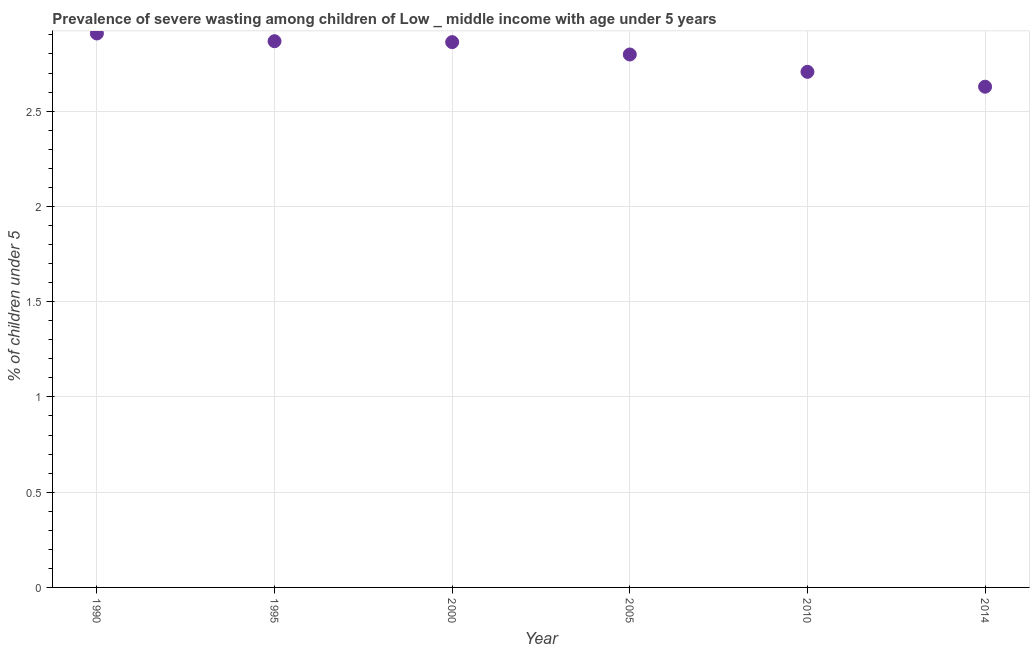What is the prevalence of severe wasting in 2005?
Your response must be concise. 2.8. Across all years, what is the maximum prevalence of severe wasting?
Ensure brevity in your answer.  2.91. Across all years, what is the minimum prevalence of severe wasting?
Keep it short and to the point. 2.63. In which year was the prevalence of severe wasting minimum?
Offer a very short reply. 2014. What is the sum of the prevalence of severe wasting?
Offer a very short reply. 16.77. What is the difference between the prevalence of severe wasting in 1995 and 2000?
Provide a short and direct response. 0. What is the average prevalence of severe wasting per year?
Ensure brevity in your answer.  2.79. What is the median prevalence of severe wasting?
Your answer should be compact. 2.83. Do a majority of the years between 2000 and 2005 (inclusive) have prevalence of severe wasting greater than 0.8 %?
Your response must be concise. Yes. What is the ratio of the prevalence of severe wasting in 1995 to that in 2000?
Keep it short and to the point. 1. Is the prevalence of severe wasting in 2005 less than that in 2010?
Provide a short and direct response. No. What is the difference between the highest and the second highest prevalence of severe wasting?
Ensure brevity in your answer.  0.04. Is the sum of the prevalence of severe wasting in 2000 and 2005 greater than the maximum prevalence of severe wasting across all years?
Provide a succinct answer. Yes. What is the difference between the highest and the lowest prevalence of severe wasting?
Your answer should be compact. 0.28. In how many years, is the prevalence of severe wasting greater than the average prevalence of severe wasting taken over all years?
Offer a very short reply. 4. Does the prevalence of severe wasting monotonically increase over the years?
Your response must be concise. No. How many years are there in the graph?
Offer a very short reply. 6. Does the graph contain grids?
Offer a very short reply. Yes. What is the title of the graph?
Provide a short and direct response. Prevalence of severe wasting among children of Low _ middle income with age under 5 years. What is the label or title of the Y-axis?
Make the answer very short.  % of children under 5. What is the  % of children under 5 in 1990?
Provide a short and direct response. 2.91. What is the  % of children under 5 in 1995?
Provide a short and direct response. 2.87. What is the  % of children under 5 in 2000?
Keep it short and to the point. 2.86. What is the  % of children under 5 in 2005?
Offer a terse response. 2.8. What is the  % of children under 5 in 2010?
Make the answer very short. 2.71. What is the  % of children under 5 in 2014?
Provide a short and direct response. 2.63. What is the difference between the  % of children under 5 in 1990 and 1995?
Give a very brief answer. 0.04. What is the difference between the  % of children under 5 in 1990 and 2000?
Offer a terse response. 0.05. What is the difference between the  % of children under 5 in 1990 and 2005?
Give a very brief answer. 0.11. What is the difference between the  % of children under 5 in 1990 and 2010?
Offer a terse response. 0.2. What is the difference between the  % of children under 5 in 1990 and 2014?
Keep it short and to the point. 0.28. What is the difference between the  % of children under 5 in 1995 and 2000?
Offer a terse response. 0. What is the difference between the  % of children under 5 in 1995 and 2005?
Your response must be concise. 0.07. What is the difference between the  % of children under 5 in 1995 and 2010?
Give a very brief answer. 0.16. What is the difference between the  % of children under 5 in 1995 and 2014?
Offer a terse response. 0.24. What is the difference between the  % of children under 5 in 2000 and 2005?
Provide a succinct answer. 0.06. What is the difference between the  % of children under 5 in 2000 and 2010?
Your response must be concise. 0.16. What is the difference between the  % of children under 5 in 2000 and 2014?
Your answer should be compact. 0.23. What is the difference between the  % of children under 5 in 2005 and 2010?
Your answer should be compact. 0.09. What is the difference between the  % of children under 5 in 2005 and 2014?
Give a very brief answer. 0.17. What is the difference between the  % of children under 5 in 2010 and 2014?
Give a very brief answer. 0.08. What is the ratio of the  % of children under 5 in 1990 to that in 1995?
Your answer should be compact. 1.01. What is the ratio of the  % of children under 5 in 1990 to that in 2005?
Your answer should be compact. 1.04. What is the ratio of the  % of children under 5 in 1990 to that in 2010?
Make the answer very short. 1.07. What is the ratio of the  % of children under 5 in 1990 to that in 2014?
Your answer should be very brief. 1.11. What is the ratio of the  % of children under 5 in 1995 to that in 2000?
Your answer should be compact. 1. What is the ratio of the  % of children under 5 in 1995 to that in 2005?
Your response must be concise. 1.02. What is the ratio of the  % of children under 5 in 1995 to that in 2010?
Your answer should be very brief. 1.06. What is the ratio of the  % of children under 5 in 1995 to that in 2014?
Your answer should be very brief. 1.09. What is the ratio of the  % of children under 5 in 2000 to that in 2010?
Ensure brevity in your answer.  1.06. What is the ratio of the  % of children under 5 in 2000 to that in 2014?
Keep it short and to the point. 1.09. What is the ratio of the  % of children under 5 in 2005 to that in 2010?
Your response must be concise. 1.03. What is the ratio of the  % of children under 5 in 2005 to that in 2014?
Ensure brevity in your answer.  1.06. What is the ratio of the  % of children under 5 in 2010 to that in 2014?
Keep it short and to the point. 1.03. 